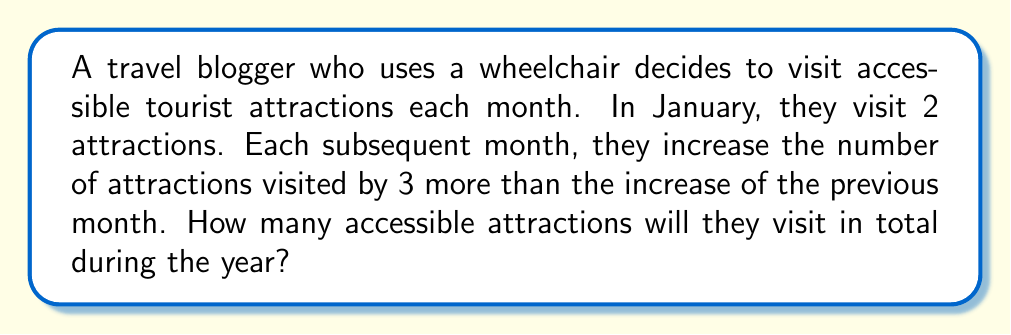Show me your answer to this math problem. Let's approach this step-by-step:

1) First, let's identify the pattern of increases:
   - From January to February: +3
   - From February to March: +6
   - From March to April: +9
   And so on...

2) We can express this as an arithmetic sequence of second order, where the difference between consecutive terms forms an arithmetic sequence.

3) Let $a_n$ be the number of attractions visited in the $n$th month. Then:
   $a_1 = 2$ (January)
   $a_2 = 2 + 3 = 5$ (February)
   $a_3 = 5 + (3 + 3) = 11$ (March)
   $a_4 = 11 + (3 + 3 + 3) = 20$ (April)
   And so on...

4) The general term for such a sequence is:
   $$a_n = a_1 + \frac{n(n-1)}{2}d$$
   Where $d$ is the common difference of the arithmetic sequence of differences (in this case, 3).

5) Substituting our values:
   $$a_n = 2 + \frac{n(n-1)}{2} \cdot 3 = 2 + \frac{3n(n-1)}{2}$$

6) To find the total number of attractions visited in the year, we need to sum this from $n=1$ to $n=12$:
   $$\sum_{n=1}^{12} (2 + \frac{3n(n-1)}{2})$$

7) This can be split into:
   $$12 \cdot 2 + \frac{3}{2} \sum_{n=1}^{12} n(n-1)$$

8) The sum $\sum_{n=1}^{12} n(n-1)$ can be evaluated using the formula for the sum of squares and the sum of natural numbers:
   $$\sum_{n=1}^{12} n(n-1) = \sum_{n=1}^{12} (n^2 - n) = \sum_{n=1}^{12} n^2 - \sum_{n=1}^{12} n$$
   $$= \frac{12 \cdot 13 \cdot 25}{6} - \frac{12 \cdot 13}{2} = 650 - 78 = 572$$

9) Substituting back:
   $$24 + \frac{3}{2} \cdot 572 = 24 + 858 = 882$$

Therefore, the travel blogger will visit 882 accessible attractions in total during the year.
Answer: 882 attractions 